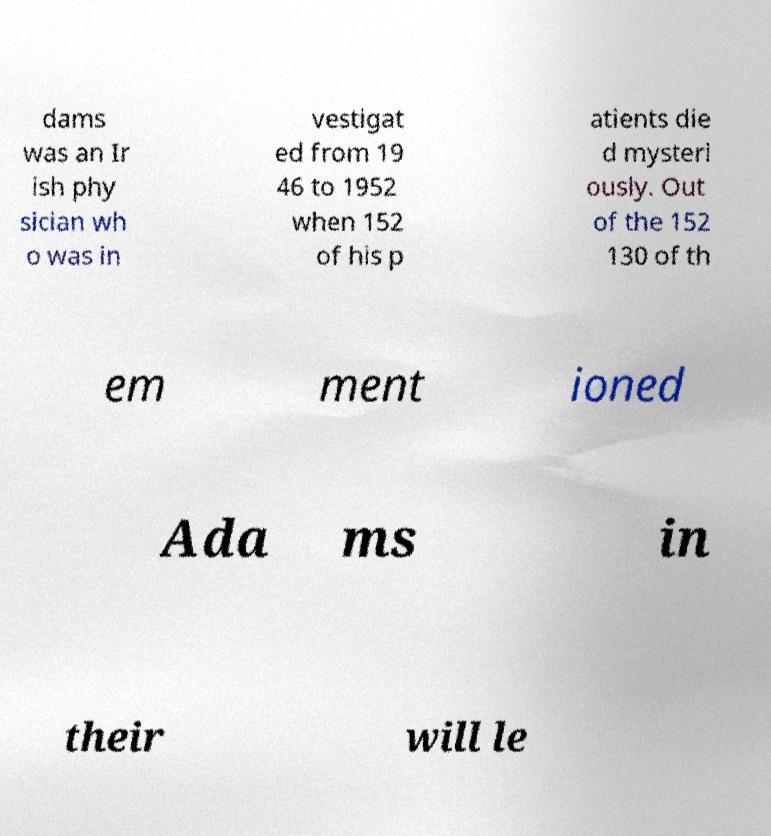Could you extract and type out the text from this image? dams was an Ir ish phy sician wh o was in vestigat ed from 19 46 to 1952 when 152 of his p atients die d mysteri ously. Out of the 152 130 of th em ment ioned Ada ms in their will le 